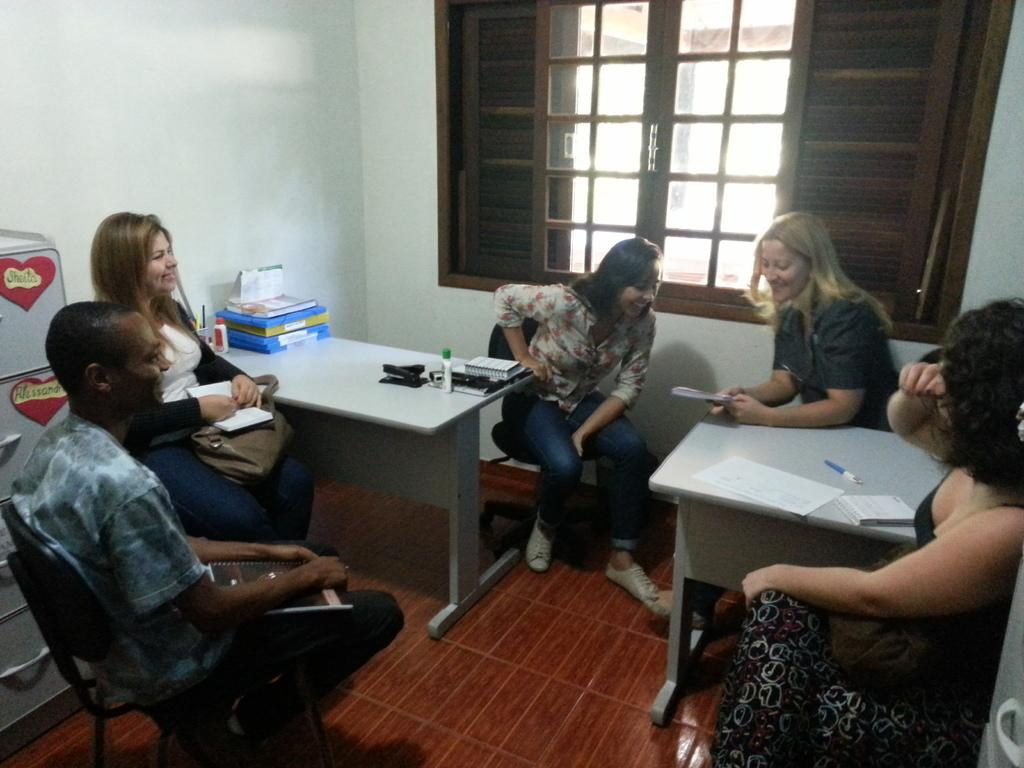What are the people in the image doing? There is a group of people sitting in chairs. What objects can be seen on the table in the image? There are books, bottles, pens, and papers on the table. What can be seen in the background of the image? There is a cupboard, a window, and a wall in the background. Can you see a snail crawling on the wall in the image? There is no snail present in the image; only the people, table, and background elements are visible. 